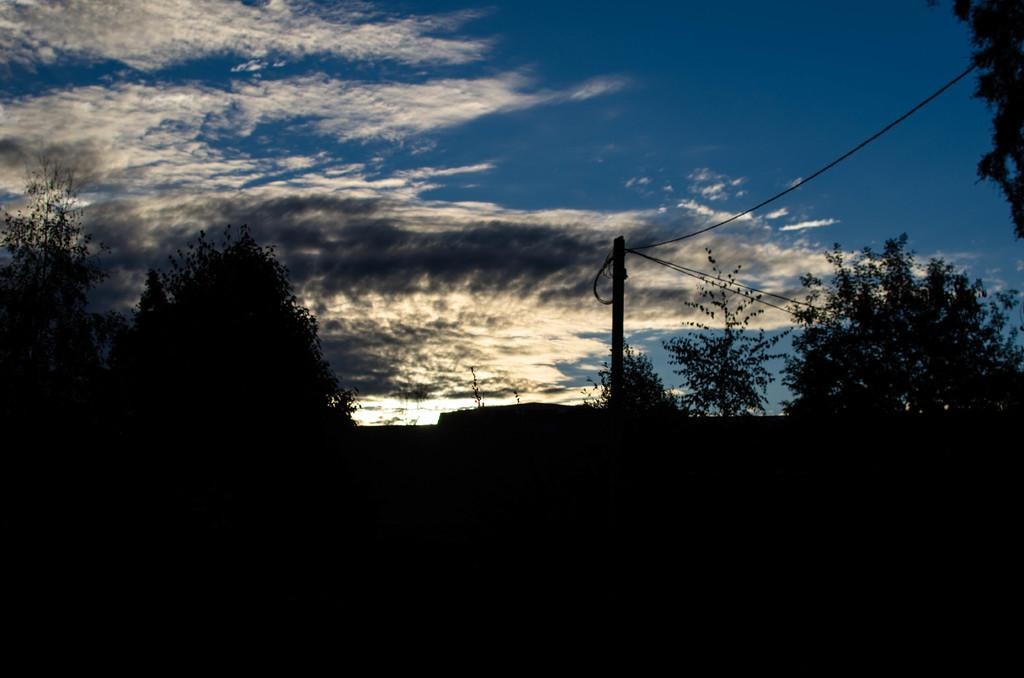What type of vegetation can be seen in the image? There are trees in the image. What object is located on the right side of the image? There is a pole on the right side of the image. What can be seen in the sky in the background of the image? There are clouds in the sky in the background of the image. Is there a field with a level ball visible in the image? There is no field or ball present in the image; it features trees and a pole. 